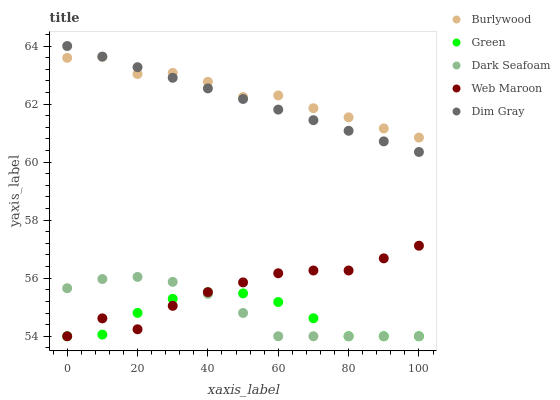Does Green have the minimum area under the curve?
Answer yes or no. Yes. Does Burlywood have the maximum area under the curve?
Answer yes or no. Yes. Does Web Maroon have the minimum area under the curve?
Answer yes or no. No. Does Web Maroon have the maximum area under the curve?
Answer yes or no. No. Is Dim Gray the smoothest?
Answer yes or no. Yes. Is Web Maroon the roughest?
Answer yes or no. Yes. Is Dark Seafoam the smoothest?
Answer yes or no. No. Is Dark Seafoam the roughest?
Answer yes or no. No. Does Web Maroon have the lowest value?
Answer yes or no. Yes. Does Dim Gray have the lowest value?
Answer yes or no. No. Does Dim Gray have the highest value?
Answer yes or no. Yes. Does Web Maroon have the highest value?
Answer yes or no. No. Is Dark Seafoam less than Dim Gray?
Answer yes or no. Yes. Is Burlywood greater than Green?
Answer yes or no. Yes. Does Dim Gray intersect Burlywood?
Answer yes or no. Yes. Is Dim Gray less than Burlywood?
Answer yes or no. No. Is Dim Gray greater than Burlywood?
Answer yes or no. No. Does Dark Seafoam intersect Dim Gray?
Answer yes or no. No. 